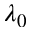<formula> <loc_0><loc_0><loc_500><loc_500>\lambda _ { 0 }</formula> 